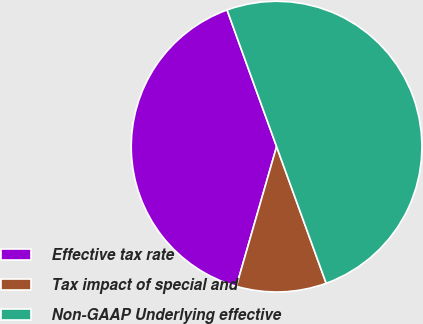<chart> <loc_0><loc_0><loc_500><loc_500><pie_chart><fcel>Effective tax rate<fcel>Tax impact of special and<fcel>Non-GAAP Underlying effective<nl><fcel>40.0%<fcel>10.0%<fcel>50.0%<nl></chart> 